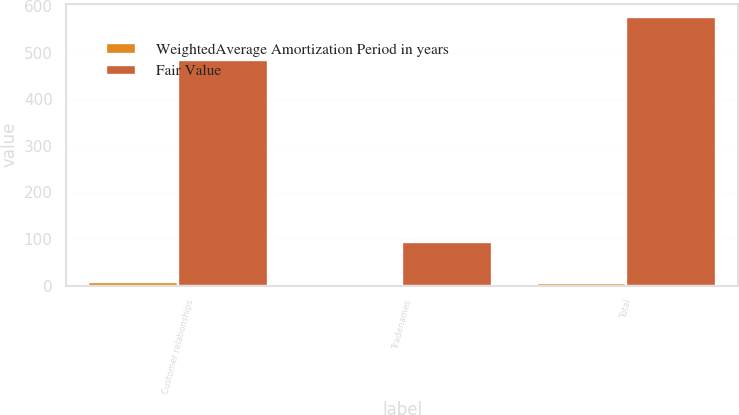Convert chart. <chart><loc_0><loc_0><loc_500><loc_500><stacked_bar_chart><ecel><fcel>Customer relationships<fcel>Tradenames<fcel>Total<nl><fcel>WeightedAverage Amortization Period in years<fcel>6.8<fcel>4.2<fcel>6.4<nl><fcel>Fair Value<fcel>484<fcel>93<fcel>577<nl></chart> 